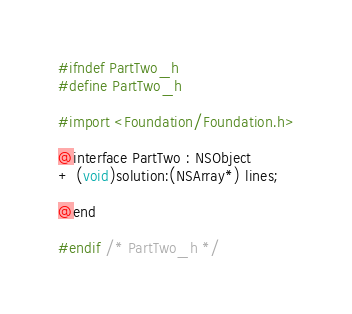Convert code to text. <code><loc_0><loc_0><loc_500><loc_500><_C_>#ifndef PartTwo_h
#define PartTwo_h

#import <Foundation/Foundation.h>

@interface PartTwo : NSObject
+ (void)solution:(NSArray*) lines;

@end

#endif /* PartTwo_h */
</code> 